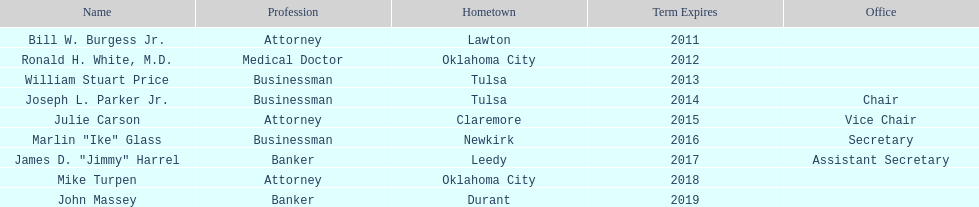How many of the existing state regents hold a documented office title? 4. 